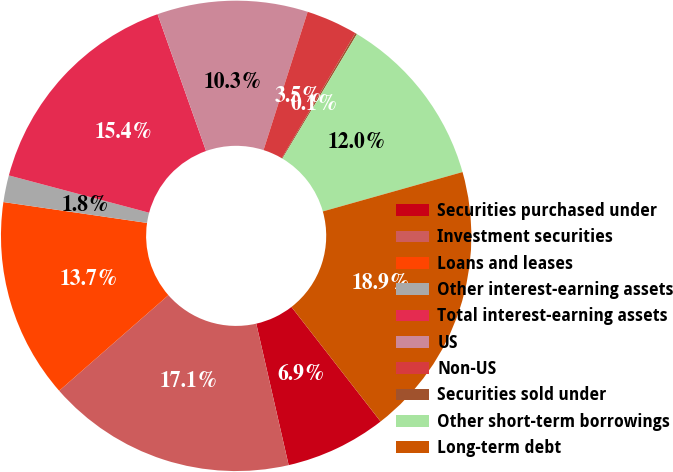Convert chart. <chart><loc_0><loc_0><loc_500><loc_500><pie_chart><fcel>Securities purchased under<fcel>Investment securities<fcel>Loans and leases<fcel>Other interest-earning assets<fcel>Total interest-earning assets<fcel>US<fcel>Non-US<fcel>Securities sold under<fcel>Other short-term borrowings<fcel>Long-term debt<nl><fcel>6.94%<fcel>17.14%<fcel>13.74%<fcel>1.84%<fcel>15.44%<fcel>10.34%<fcel>3.54%<fcel>0.13%<fcel>12.04%<fcel>18.85%<nl></chart> 